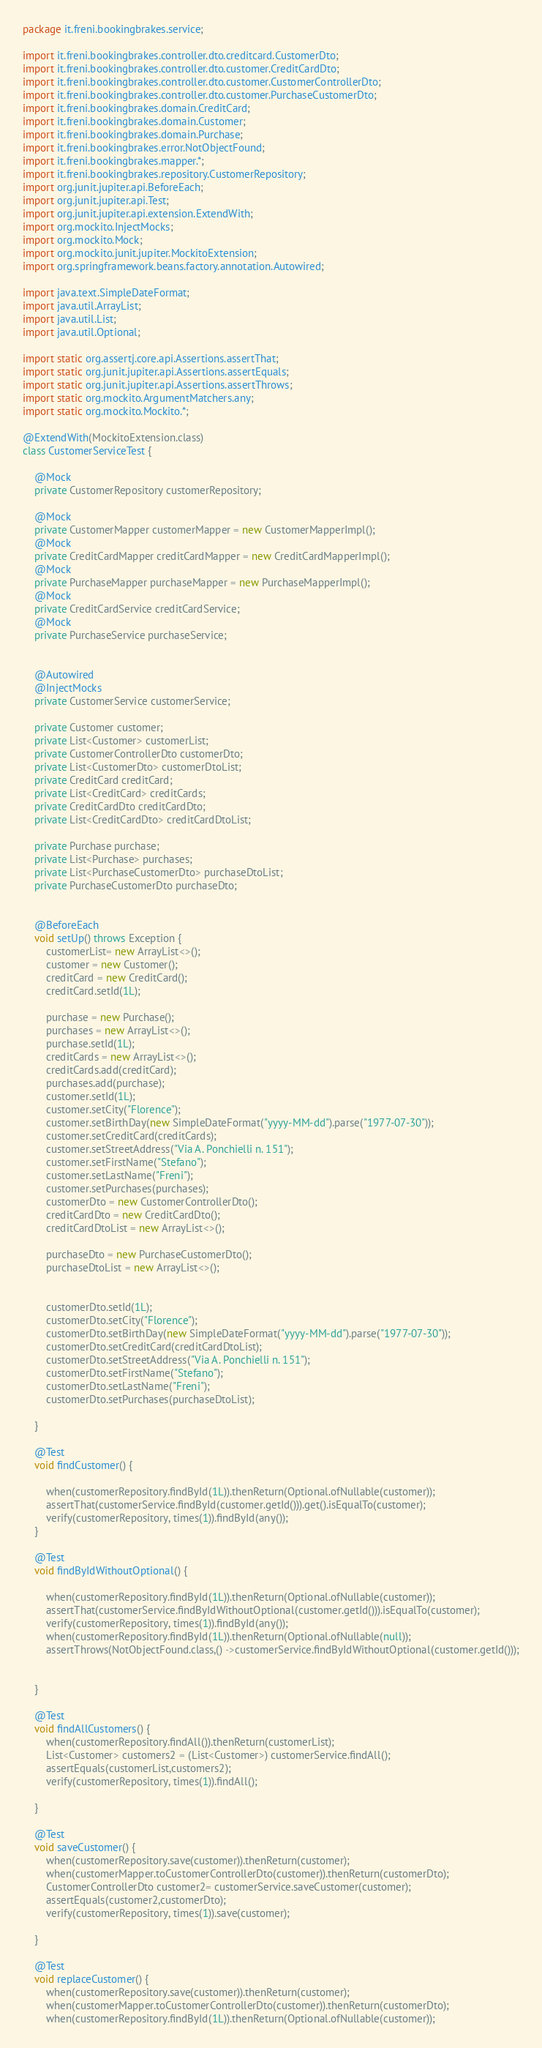<code> <loc_0><loc_0><loc_500><loc_500><_Java_>package it.freni.bookingbrakes.service;

import it.freni.bookingbrakes.controller.dto.creditcard.CustomerDto;
import it.freni.bookingbrakes.controller.dto.customer.CreditCardDto;
import it.freni.bookingbrakes.controller.dto.customer.CustomerControllerDto;
import it.freni.bookingbrakes.controller.dto.customer.PurchaseCustomerDto;
import it.freni.bookingbrakes.domain.CreditCard;
import it.freni.bookingbrakes.domain.Customer;
import it.freni.bookingbrakes.domain.Purchase;
import it.freni.bookingbrakes.error.NotObjectFound;
import it.freni.bookingbrakes.mapper.*;
import it.freni.bookingbrakes.repository.CustomerRepository;
import org.junit.jupiter.api.BeforeEach;
import org.junit.jupiter.api.Test;
import org.junit.jupiter.api.extension.ExtendWith;
import org.mockito.InjectMocks;
import org.mockito.Mock;
import org.mockito.junit.jupiter.MockitoExtension;
import org.springframework.beans.factory.annotation.Autowired;

import java.text.SimpleDateFormat;
import java.util.ArrayList;
import java.util.List;
import java.util.Optional;

import static org.assertj.core.api.Assertions.assertThat;
import static org.junit.jupiter.api.Assertions.assertEquals;
import static org.junit.jupiter.api.Assertions.assertThrows;
import static org.mockito.ArgumentMatchers.any;
import static org.mockito.Mockito.*;

@ExtendWith(MockitoExtension.class)
class CustomerServiceTest {

    @Mock
    private CustomerRepository customerRepository;

    @Mock
    private CustomerMapper customerMapper = new CustomerMapperImpl();
    @Mock
    private CreditCardMapper creditCardMapper = new CreditCardMapperImpl();
    @Mock
    private PurchaseMapper purchaseMapper = new PurchaseMapperImpl();
    @Mock
    private CreditCardService creditCardService;
    @Mock
    private PurchaseService purchaseService;


    @Autowired
    @InjectMocks
    private CustomerService customerService;

    private Customer customer;
    private List<Customer> customerList;
    private CustomerControllerDto customerDto;
    private List<CustomerDto> customerDtoList;
    private CreditCard creditCard;
    private List<CreditCard> creditCards;
    private CreditCardDto creditCardDto;
    private List<CreditCardDto> creditCardDtoList;

    private Purchase purchase;
    private List<Purchase> purchases;
    private List<PurchaseCustomerDto> purchaseDtoList;
    private PurchaseCustomerDto purchaseDto;


    @BeforeEach
    void setUp() throws Exception {
        customerList= new ArrayList<>();
        customer = new Customer();
        creditCard = new CreditCard();
        creditCard.setId(1L);

        purchase = new Purchase();
        purchases = new ArrayList<>();
        purchase.setId(1L);
        creditCards = new ArrayList<>();
        creditCards.add(creditCard);
        purchases.add(purchase);
        customer.setId(1L);
        customer.setCity("Florence");
        customer.setBirthDay(new SimpleDateFormat("yyyy-MM-dd").parse("1977-07-30"));
        customer.setCreditCard(creditCards);
        customer.setStreetAddress("Via A. Ponchielli n. 151");
        customer.setFirstName("Stefano");
        customer.setLastName("Freni");
        customer.setPurchases(purchases);
        customerDto = new CustomerControllerDto();
        creditCardDto = new CreditCardDto();
        creditCardDtoList = new ArrayList<>();

        purchaseDto = new PurchaseCustomerDto();
        purchaseDtoList = new ArrayList<>();


        customerDto.setId(1L);
        customerDto.setCity("Florence");
        customerDto.setBirthDay(new SimpleDateFormat("yyyy-MM-dd").parse("1977-07-30"));
        customerDto.setCreditCard(creditCardDtoList);
        customerDto.setStreetAddress("Via A. Ponchielli n. 151");
        customerDto.setFirstName("Stefano");
        customerDto.setLastName("Freni");
        customerDto.setPurchases(purchaseDtoList);

    }

    @Test
    void findCustomer() {

        when(customerRepository.findById(1L)).thenReturn(Optional.ofNullable(customer));
        assertThat(customerService.findById(customer.getId())).get().isEqualTo(customer);
        verify(customerRepository, times(1)).findById(any());
    }

    @Test
    void findByIdWithoutOptional() {

        when(customerRepository.findById(1L)).thenReturn(Optional.ofNullable(customer));
        assertThat(customerService.findByIdWithoutOptional(customer.getId())).isEqualTo(customer);
        verify(customerRepository, times(1)).findById(any());
        when(customerRepository.findById(1L)).thenReturn(Optional.ofNullable(null));
        assertThrows(NotObjectFound.class,() ->customerService.findByIdWithoutOptional(customer.getId()));


    }

    @Test
    void findAllCustomers() {
        when(customerRepository.findAll()).thenReturn(customerList);
        List<Customer> customers2 = (List<Customer>) customerService.findAll();
        assertEquals(customerList,customers2);
        verify(customerRepository, times(1)).findAll();

    }

    @Test
    void saveCustomer() {
        when(customerRepository.save(customer)).thenReturn(customer);
        when(customerMapper.toCustomerControllerDto(customer)).thenReturn(customerDto);
        CustomerControllerDto customer2= customerService.saveCustomer(customer);
        assertEquals(customer2,customerDto);
        verify(customerRepository, times(1)).save(customer);

    }

    @Test
    void replaceCustomer() {
        when(customerRepository.save(customer)).thenReturn(customer);
        when(customerMapper.toCustomerControllerDto(customer)).thenReturn(customerDto);
        when(customerRepository.findById(1L)).thenReturn(Optional.ofNullable(customer));</code> 